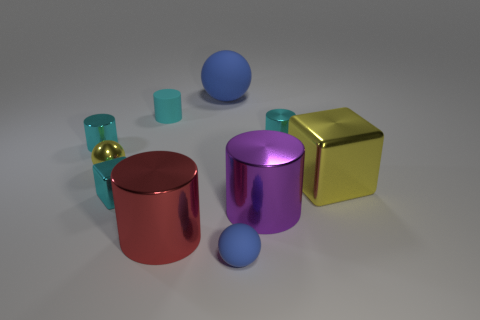Subtract all blue blocks. How many cyan cylinders are left? 3 Subtract 1 cylinders. How many cylinders are left? 4 Subtract all cyan rubber cylinders. How many cylinders are left? 4 Subtract all gray cylinders. Subtract all gray cubes. How many cylinders are left? 5 Subtract all balls. How many objects are left? 7 Add 6 tiny matte balls. How many tiny matte balls are left? 7 Add 7 small yellow balls. How many small yellow balls exist? 8 Subtract 1 blue spheres. How many objects are left? 9 Subtract all small gray metallic cylinders. Subtract all purple objects. How many objects are left? 9 